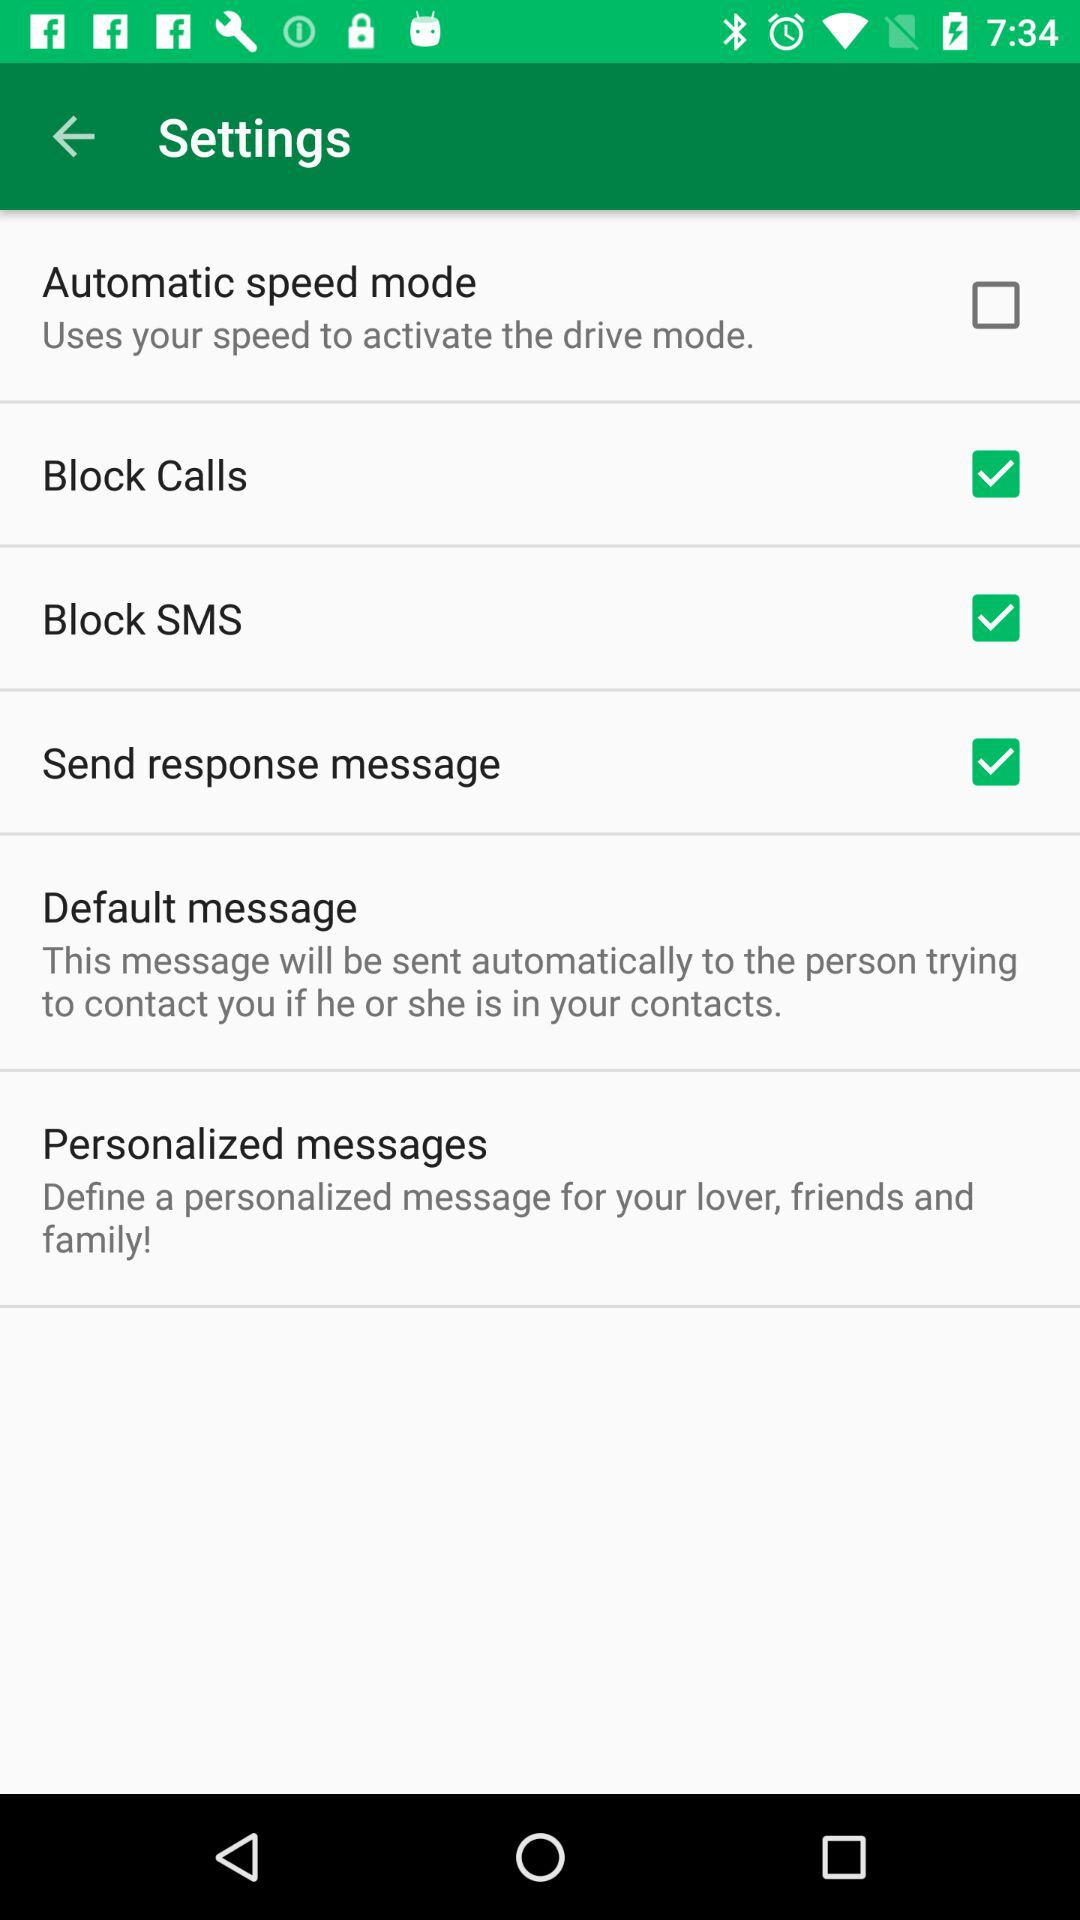What option is not selected? The option is "Automatic speed mode". 